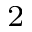<formula> <loc_0><loc_0><loc_500><loc_500>^ { 2 }</formula> 